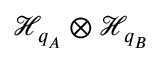<formula> <loc_0><loc_0><loc_500><loc_500>\mathcal { H } _ { q _ { A } } \otimes \mathcal { H } _ { q _ { B } }</formula> 